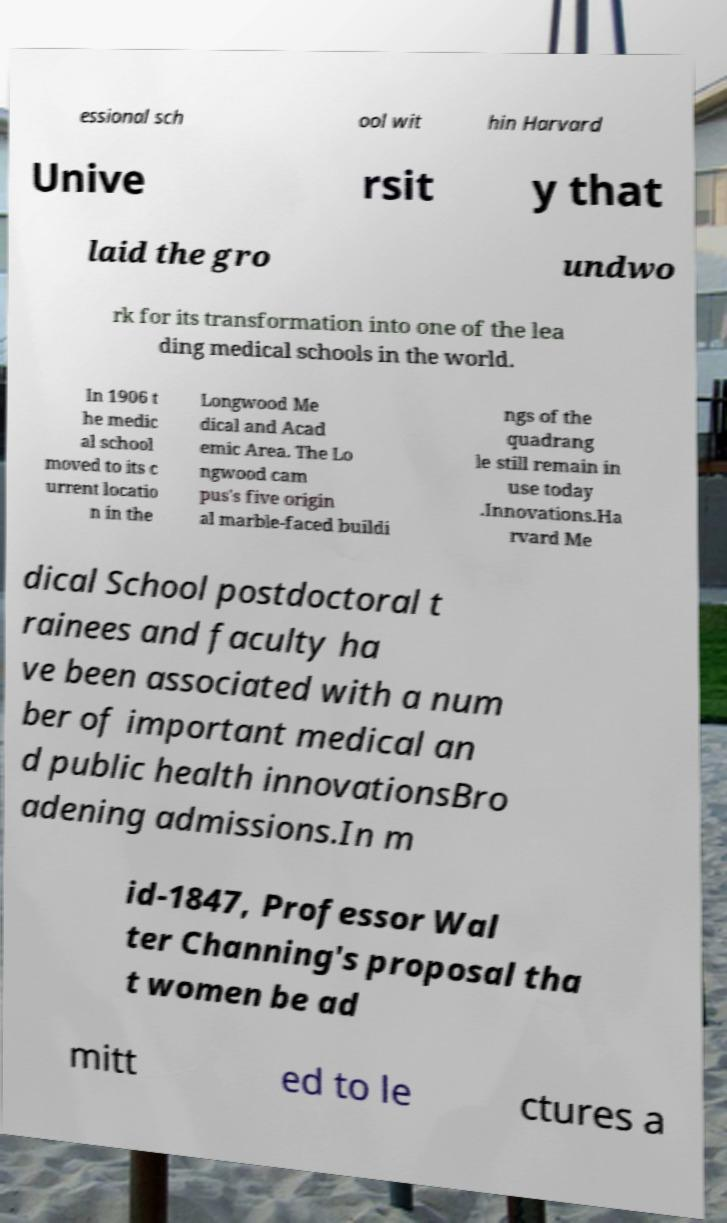Can you read and provide the text displayed in the image?This photo seems to have some interesting text. Can you extract and type it out for me? essional sch ool wit hin Harvard Unive rsit y that laid the gro undwo rk for its transformation into one of the lea ding medical schools in the world. In 1906 t he medic al school moved to its c urrent locatio n in the Longwood Me dical and Acad emic Area. The Lo ngwood cam pus's five origin al marble-faced buildi ngs of the quadrang le still remain in use today .Innovations.Ha rvard Me dical School postdoctoral t rainees and faculty ha ve been associated with a num ber of important medical an d public health innovationsBro adening admissions.In m id-1847, Professor Wal ter Channing's proposal tha t women be ad mitt ed to le ctures a 